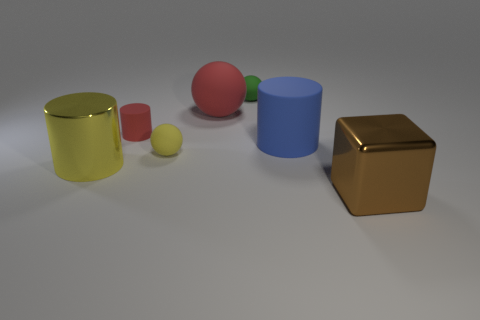Add 2 green objects. How many objects exist? 9 Subtract all spheres. How many objects are left? 4 Subtract all tiny green matte things. Subtract all blue matte cylinders. How many objects are left? 5 Add 3 tiny rubber cylinders. How many tiny rubber cylinders are left? 4 Add 5 big red rubber spheres. How many big red rubber spheres exist? 6 Subtract 0 cyan blocks. How many objects are left? 7 